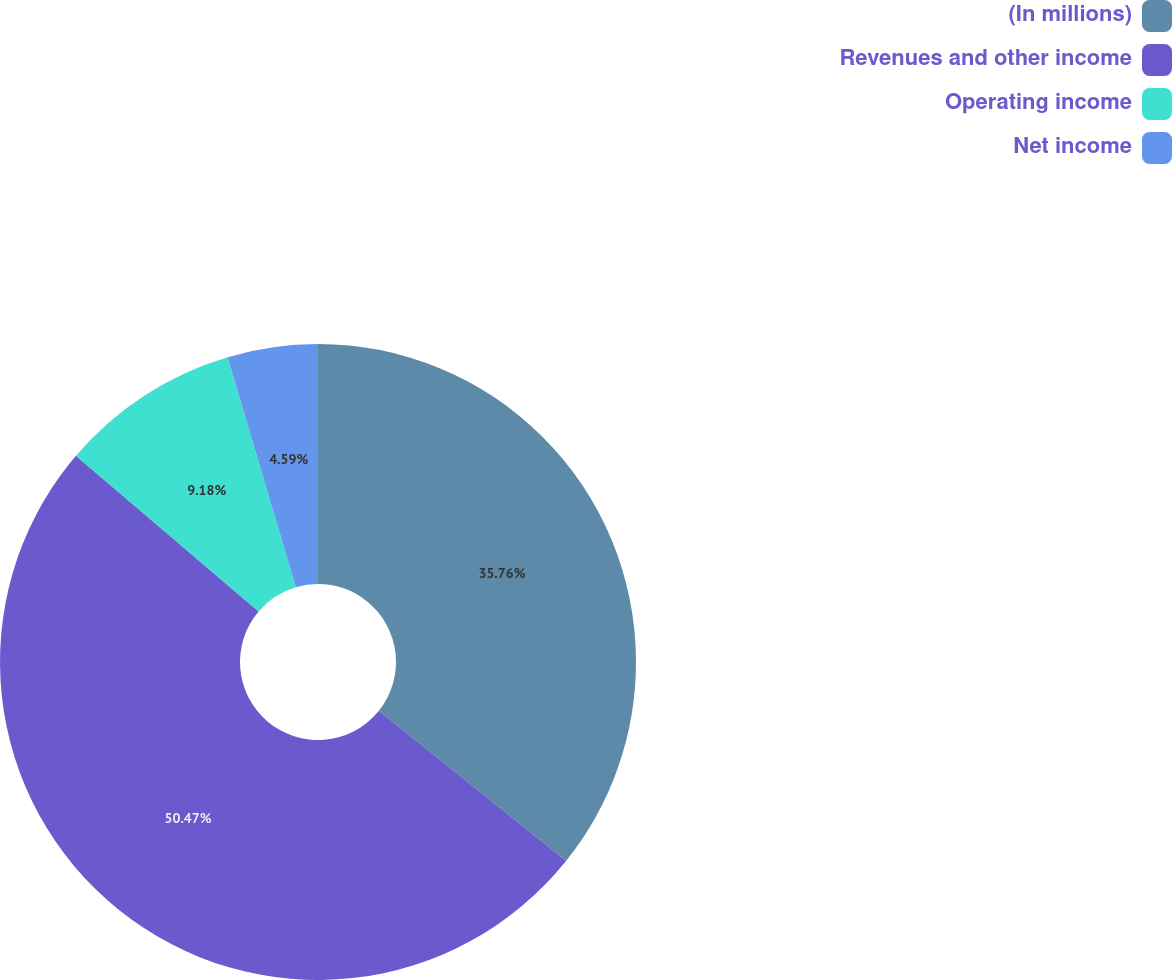<chart> <loc_0><loc_0><loc_500><loc_500><pie_chart><fcel>(In millions)<fcel>Revenues and other income<fcel>Operating income<fcel>Net income<nl><fcel>35.76%<fcel>50.47%<fcel>9.18%<fcel>4.59%<nl></chart> 